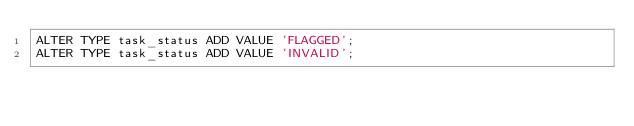<code> <loc_0><loc_0><loc_500><loc_500><_SQL_>ALTER TYPE task_status ADD VALUE 'FLAGGED';
ALTER TYPE task_status ADD VALUE 'INVALID';
</code> 